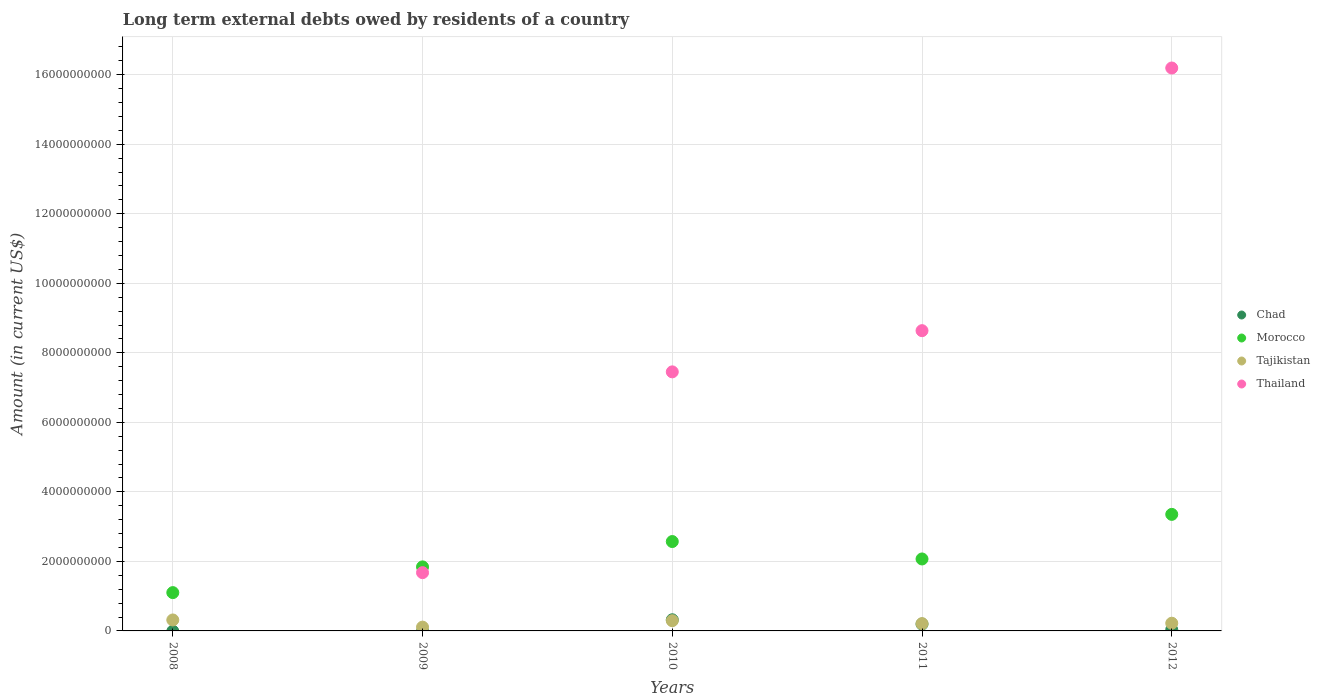How many different coloured dotlines are there?
Provide a succinct answer. 4. Is the number of dotlines equal to the number of legend labels?
Provide a short and direct response. No. What is the amount of long-term external debts owed by residents in Tajikistan in 2012?
Offer a terse response. 2.22e+08. Across all years, what is the maximum amount of long-term external debts owed by residents in Morocco?
Give a very brief answer. 3.35e+09. Across all years, what is the minimum amount of long-term external debts owed by residents in Chad?
Your answer should be very brief. 0. In which year was the amount of long-term external debts owed by residents in Chad maximum?
Your answer should be very brief. 2010. What is the total amount of long-term external debts owed by residents in Thailand in the graph?
Make the answer very short. 3.40e+1. What is the difference between the amount of long-term external debts owed by residents in Tajikistan in 2008 and that in 2012?
Make the answer very short. 9.38e+07. What is the difference between the amount of long-term external debts owed by residents in Chad in 2008 and the amount of long-term external debts owed by residents in Thailand in 2010?
Offer a terse response. -7.45e+09. What is the average amount of long-term external debts owed by residents in Tajikistan per year?
Make the answer very short. 2.30e+08. In the year 2011, what is the difference between the amount of long-term external debts owed by residents in Thailand and amount of long-term external debts owed by residents in Chad?
Offer a terse response. 8.44e+09. What is the ratio of the amount of long-term external debts owed by residents in Tajikistan in 2010 to that in 2012?
Provide a short and direct response. 1.33. Is the amount of long-term external debts owed by residents in Tajikistan in 2008 less than that in 2010?
Provide a short and direct response. No. What is the difference between the highest and the second highest amount of long-term external debts owed by residents in Tajikistan?
Ensure brevity in your answer.  2.15e+07. What is the difference between the highest and the lowest amount of long-term external debts owed by residents in Chad?
Your answer should be very brief. 3.21e+08. In how many years, is the amount of long-term external debts owed by residents in Tajikistan greater than the average amount of long-term external debts owed by residents in Tajikistan taken over all years?
Make the answer very short. 2. Is the sum of the amount of long-term external debts owed by residents in Morocco in 2011 and 2012 greater than the maximum amount of long-term external debts owed by residents in Chad across all years?
Keep it short and to the point. Yes. Is it the case that in every year, the sum of the amount of long-term external debts owed by residents in Tajikistan and amount of long-term external debts owed by residents in Thailand  is greater than the sum of amount of long-term external debts owed by residents in Chad and amount of long-term external debts owed by residents in Morocco?
Keep it short and to the point. No. Does the amount of long-term external debts owed by residents in Chad monotonically increase over the years?
Provide a succinct answer. No. How many years are there in the graph?
Your response must be concise. 5. What is the difference between two consecutive major ticks on the Y-axis?
Your answer should be very brief. 2.00e+09. Where does the legend appear in the graph?
Your response must be concise. Center right. What is the title of the graph?
Offer a very short reply. Long term external debts owed by residents of a country. Does "Barbados" appear as one of the legend labels in the graph?
Offer a terse response. No. What is the label or title of the Y-axis?
Keep it short and to the point. Amount (in current US$). What is the Amount (in current US$) in Chad in 2008?
Ensure brevity in your answer.  0. What is the Amount (in current US$) of Morocco in 2008?
Keep it short and to the point. 1.10e+09. What is the Amount (in current US$) in Tajikistan in 2008?
Your answer should be very brief. 3.15e+08. What is the Amount (in current US$) of Thailand in 2008?
Ensure brevity in your answer.  0. What is the Amount (in current US$) in Morocco in 2009?
Your answer should be very brief. 1.84e+09. What is the Amount (in current US$) of Tajikistan in 2009?
Make the answer very short. 1.09e+08. What is the Amount (in current US$) of Thailand in 2009?
Make the answer very short. 1.68e+09. What is the Amount (in current US$) in Chad in 2010?
Make the answer very short. 3.21e+08. What is the Amount (in current US$) of Morocco in 2010?
Give a very brief answer. 2.57e+09. What is the Amount (in current US$) in Tajikistan in 2010?
Keep it short and to the point. 2.94e+08. What is the Amount (in current US$) in Thailand in 2010?
Your response must be concise. 7.45e+09. What is the Amount (in current US$) of Chad in 2011?
Provide a short and direct response. 1.97e+08. What is the Amount (in current US$) in Morocco in 2011?
Give a very brief answer. 2.07e+09. What is the Amount (in current US$) of Tajikistan in 2011?
Provide a succinct answer. 2.10e+08. What is the Amount (in current US$) of Thailand in 2011?
Ensure brevity in your answer.  8.64e+09. What is the Amount (in current US$) in Chad in 2012?
Ensure brevity in your answer.  3.60e+07. What is the Amount (in current US$) in Morocco in 2012?
Provide a succinct answer. 3.35e+09. What is the Amount (in current US$) of Tajikistan in 2012?
Your answer should be very brief. 2.22e+08. What is the Amount (in current US$) in Thailand in 2012?
Offer a terse response. 1.62e+1. Across all years, what is the maximum Amount (in current US$) in Chad?
Provide a succinct answer. 3.21e+08. Across all years, what is the maximum Amount (in current US$) of Morocco?
Give a very brief answer. 3.35e+09. Across all years, what is the maximum Amount (in current US$) of Tajikistan?
Provide a succinct answer. 3.15e+08. Across all years, what is the maximum Amount (in current US$) in Thailand?
Ensure brevity in your answer.  1.62e+1. Across all years, what is the minimum Amount (in current US$) in Morocco?
Your answer should be compact. 1.10e+09. Across all years, what is the minimum Amount (in current US$) of Tajikistan?
Ensure brevity in your answer.  1.09e+08. Across all years, what is the minimum Amount (in current US$) of Thailand?
Give a very brief answer. 0. What is the total Amount (in current US$) in Chad in the graph?
Provide a succinct answer. 5.54e+08. What is the total Amount (in current US$) in Morocco in the graph?
Your response must be concise. 1.09e+1. What is the total Amount (in current US$) in Tajikistan in the graph?
Your answer should be very brief. 1.15e+09. What is the total Amount (in current US$) of Thailand in the graph?
Your answer should be compact. 3.40e+1. What is the difference between the Amount (in current US$) of Morocco in 2008 and that in 2009?
Your answer should be compact. -7.40e+08. What is the difference between the Amount (in current US$) of Tajikistan in 2008 and that in 2009?
Your response must be concise. 2.06e+08. What is the difference between the Amount (in current US$) in Morocco in 2008 and that in 2010?
Provide a short and direct response. -1.47e+09. What is the difference between the Amount (in current US$) of Tajikistan in 2008 and that in 2010?
Give a very brief answer. 2.15e+07. What is the difference between the Amount (in current US$) of Morocco in 2008 and that in 2011?
Make the answer very short. -9.68e+08. What is the difference between the Amount (in current US$) of Tajikistan in 2008 and that in 2011?
Offer a terse response. 1.05e+08. What is the difference between the Amount (in current US$) of Morocco in 2008 and that in 2012?
Offer a terse response. -2.25e+09. What is the difference between the Amount (in current US$) of Tajikistan in 2008 and that in 2012?
Offer a terse response. 9.38e+07. What is the difference between the Amount (in current US$) of Morocco in 2009 and that in 2010?
Offer a very short reply. -7.29e+08. What is the difference between the Amount (in current US$) of Tajikistan in 2009 and that in 2010?
Your response must be concise. -1.85e+08. What is the difference between the Amount (in current US$) in Thailand in 2009 and that in 2010?
Make the answer very short. -5.78e+09. What is the difference between the Amount (in current US$) of Morocco in 2009 and that in 2011?
Your answer should be compact. -2.28e+08. What is the difference between the Amount (in current US$) of Tajikistan in 2009 and that in 2011?
Your answer should be compact. -1.01e+08. What is the difference between the Amount (in current US$) in Thailand in 2009 and that in 2011?
Ensure brevity in your answer.  -6.96e+09. What is the difference between the Amount (in current US$) of Morocco in 2009 and that in 2012?
Offer a terse response. -1.51e+09. What is the difference between the Amount (in current US$) of Tajikistan in 2009 and that in 2012?
Provide a succinct answer. -1.12e+08. What is the difference between the Amount (in current US$) in Thailand in 2009 and that in 2012?
Your answer should be very brief. -1.45e+1. What is the difference between the Amount (in current US$) of Chad in 2010 and that in 2011?
Your answer should be compact. 1.24e+08. What is the difference between the Amount (in current US$) in Morocco in 2010 and that in 2011?
Your answer should be very brief. 5.01e+08. What is the difference between the Amount (in current US$) of Tajikistan in 2010 and that in 2011?
Your response must be concise. 8.36e+07. What is the difference between the Amount (in current US$) of Thailand in 2010 and that in 2011?
Give a very brief answer. -1.19e+09. What is the difference between the Amount (in current US$) of Chad in 2010 and that in 2012?
Your answer should be very brief. 2.85e+08. What is the difference between the Amount (in current US$) in Morocco in 2010 and that in 2012?
Provide a short and direct response. -7.81e+08. What is the difference between the Amount (in current US$) in Tajikistan in 2010 and that in 2012?
Give a very brief answer. 7.23e+07. What is the difference between the Amount (in current US$) in Thailand in 2010 and that in 2012?
Give a very brief answer. -8.74e+09. What is the difference between the Amount (in current US$) in Chad in 2011 and that in 2012?
Offer a very short reply. 1.61e+08. What is the difference between the Amount (in current US$) in Morocco in 2011 and that in 2012?
Ensure brevity in your answer.  -1.28e+09. What is the difference between the Amount (in current US$) in Tajikistan in 2011 and that in 2012?
Offer a very short reply. -1.13e+07. What is the difference between the Amount (in current US$) of Thailand in 2011 and that in 2012?
Ensure brevity in your answer.  -7.56e+09. What is the difference between the Amount (in current US$) of Morocco in 2008 and the Amount (in current US$) of Tajikistan in 2009?
Provide a short and direct response. 9.93e+08. What is the difference between the Amount (in current US$) in Morocco in 2008 and the Amount (in current US$) in Thailand in 2009?
Ensure brevity in your answer.  -5.74e+08. What is the difference between the Amount (in current US$) of Tajikistan in 2008 and the Amount (in current US$) of Thailand in 2009?
Give a very brief answer. -1.36e+09. What is the difference between the Amount (in current US$) of Morocco in 2008 and the Amount (in current US$) of Tajikistan in 2010?
Your answer should be very brief. 8.08e+08. What is the difference between the Amount (in current US$) in Morocco in 2008 and the Amount (in current US$) in Thailand in 2010?
Your answer should be very brief. -6.35e+09. What is the difference between the Amount (in current US$) of Tajikistan in 2008 and the Amount (in current US$) of Thailand in 2010?
Offer a terse response. -7.14e+09. What is the difference between the Amount (in current US$) of Morocco in 2008 and the Amount (in current US$) of Tajikistan in 2011?
Make the answer very short. 8.92e+08. What is the difference between the Amount (in current US$) in Morocco in 2008 and the Amount (in current US$) in Thailand in 2011?
Your answer should be compact. -7.54e+09. What is the difference between the Amount (in current US$) of Tajikistan in 2008 and the Amount (in current US$) of Thailand in 2011?
Your response must be concise. -8.32e+09. What is the difference between the Amount (in current US$) of Morocco in 2008 and the Amount (in current US$) of Tajikistan in 2012?
Offer a very short reply. 8.80e+08. What is the difference between the Amount (in current US$) of Morocco in 2008 and the Amount (in current US$) of Thailand in 2012?
Your answer should be very brief. -1.51e+1. What is the difference between the Amount (in current US$) of Tajikistan in 2008 and the Amount (in current US$) of Thailand in 2012?
Offer a terse response. -1.59e+1. What is the difference between the Amount (in current US$) of Morocco in 2009 and the Amount (in current US$) of Tajikistan in 2010?
Your response must be concise. 1.55e+09. What is the difference between the Amount (in current US$) in Morocco in 2009 and the Amount (in current US$) in Thailand in 2010?
Make the answer very short. -5.61e+09. What is the difference between the Amount (in current US$) of Tajikistan in 2009 and the Amount (in current US$) of Thailand in 2010?
Your answer should be very brief. -7.34e+09. What is the difference between the Amount (in current US$) in Morocco in 2009 and the Amount (in current US$) in Tajikistan in 2011?
Provide a succinct answer. 1.63e+09. What is the difference between the Amount (in current US$) in Morocco in 2009 and the Amount (in current US$) in Thailand in 2011?
Make the answer very short. -6.80e+09. What is the difference between the Amount (in current US$) in Tajikistan in 2009 and the Amount (in current US$) in Thailand in 2011?
Ensure brevity in your answer.  -8.53e+09. What is the difference between the Amount (in current US$) in Morocco in 2009 and the Amount (in current US$) in Tajikistan in 2012?
Provide a succinct answer. 1.62e+09. What is the difference between the Amount (in current US$) of Morocco in 2009 and the Amount (in current US$) of Thailand in 2012?
Ensure brevity in your answer.  -1.44e+1. What is the difference between the Amount (in current US$) of Tajikistan in 2009 and the Amount (in current US$) of Thailand in 2012?
Make the answer very short. -1.61e+1. What is the difference between the Amount (in current US$) of Chad in 2010 and the Amount (in current US$) of Morocco in 2011?
Offer a very short reply. -1.75e+09. What is the difference between the Amount (in current US$) of Chad in 2010 and the Amount (in current US$) of Tajikistan in 2011?
Provide a short and direct response. 1.10e+08. What is the difference between the Amount (in current US$) of Chad in 2010 and the Amount (in current US$) of Thailand in 2011?
Provide a succinct answer. -8.32e+09. What is the difference between the Amount (in current US$) in Morocco in 2010 and the Amount (in current US$) in Tajikistan in 2011?
Make the answer very short. 2.36e+09. What is the difference between the Amount (in current US$) of Morocco in 2010 and the Amount (in current US$) of Thailand in 2011?
Offer a very short reply. -6.07e+09. What is the difference between the Amount (in current US$) of Tajikistan in 2010 and the Amount (in current US$) of Thailand in 2011?
Ensure brevity in your answer.  -8.34e+09. What is the difference between the Amount (in current US$) of Chad in 2010 and the Amount (in current US$) of Morocco in 2012?
Give a very brief answer. -3.03e+09. What is the difference between the Amount (in current US$) in Chad in 2010 and the Amount (in current US$) in Tajikistan in 2012?
Provide a short and direct response. 9.90e+07. What is the difference between the Amount (in current US$) of Chad in 2010 and the Amount (in current US$) of Thailand in 2012?
Offer a terse response. -1.59e+1. What is the difference between the Amount (in current US$) of Morocco in 2010 and the Amount (in current US$) of Tajikistan in 2012?
Your answer should be compact. 2.35e+09. What is the difference between the Amount (in current US$) in Morocco in 2010 and the Amount (in current US$) in Thailand in 2012?
Provide a succinct answer. -1.36e+1. What is the difference between the Amount (in current US$) in Tajikistan in 2010 and the Amount (in current US$) in Thailand in 2012?
Keep it short and to the point. -1.59e+1. What is the difference between the Amount (in current US$) of Chad in 2011 and the Amount (in current US$) of Morocco in 2012?
Provide a short and direct response. -3.16e+09. What is the difference between the Amount (in current US$) in Chad in 2011 and the Amount (in current US$) in Tajikistan in 2012?
Offer a terse response. -2.48e+07. What is the difference between the Amount (in current US$) in Chad in 2011 and the Amount (in current US$) in Thailand in 2012?
Ensure brevity in your answer.  -1.60e+1. What is the difference between the Amount (in current US$) in Morocco in 2011 and the Amount (in current US$) in Tajikistan in 2012?
Keep it short and to the point. 1.85e+09. What is the difference between the Amount (in current US$) in Morocco in 2011 and the Amount (in current US$) in Thailand in 2012?
Provide a short and direct response. -1.41e+1. What is the difference between the Amount (in current US$) in Tajikistan in 2011 and the Amount (in current US$) in Thailand in 2012?
Provide a short and direct response. -1.60e+1. What is the average Amount (in current US$) in Chad per year?
Provide a succinct answer. 1.11e+08. What is the average Amount (in current US$) in Morocco per year?
Your answer should be compact. 2.19e+09. What is the average Amount (in current US$) in Tajikistan per year?
Make the answer very short. 2.30e+08. What is the average Amount (in current US$) in Thailand per year?
Give a very brief answer. 6.79e+09. In the year 2008, what is the difference between the Amount (in current US$) in Morocco and Amount (in current US$) in Tajikistan?
Keep it short and to the point. 7.86e+08. In the year 2009, what is the difference between the Amount (in current US$) of Morocco and Amount (in current US$) of Tajikistan?
Keep it short and to the point. 1.73e+09. In the year 2009, what is the difference between the Amount (in current US$) in Morocco and Amount (in current US$) in Thailand?
Your answer should be very brief. 1.66e+08. In the year 2009, what is the difference between the Amount (in current US$) in Tajikistan and Amount (in current US$) in Thailand?
Your answer should be compact. -1.57e+09. In the year 2010, what is the difference between the Amount (in current US$) in Chad and Amount (in current US$) in Morocco?
Your response must be concise. -2.25e+09. In the year 2010, what is the difference between the Amount (in current US$) in Chad and Amount (in current US$) in Tajikistan?
Make the answer very short. 2.67e+07. In the year 2010, what is the difference between the Amount (in current US$) of Chad and Amount (in current US$) of Thailand?
Your response must be concise. -7.13e+09. In the year 2010, what is the difference between the Amount (in current US$) in Morocco and Amount (in current US$) in Tajikistan?
Keep it short and to the point. 2.28e+09. In the year 2010, what is the difference between the Amount (in current US$) in Morocco and Amount (in current US$) in Thailand?
Ensure brevity in your answer.  -4.88e+09. In the year 2010, what is the difference between the Amount (in current US$) of Tajikistan and Amount (in current US$) of Thailand?
Your answer should be compact. -7.16e+09. In the year 2011, what is the difference between the Amount (in current US$) in Chad and Amount (in current US$) in Morocco?
Give a very brief answer. -1.87e+09. In the year 2011, what is the difference between the Amount (in current US$) of Chad and Amount (in current US$) of Tajikistan?
Make the answer very short. -1.35e+07. In the year 2011, what is the difference between the Amount (in current US$) in Chad and Amount (in current US$) in Thailand?
Give a very brief answer. -8.44e+09. In the year 2011, what is the difference between the Amount (in current US$) of Morocco and Amount (in current US$) of Tajikistan?
Your answer should be very brief. 1.86e+09. In the year 2011, what is the difference between the Amount (in current US$) of Morocco and Amount (in current US$) of Thailand?
Keep it short and to the point. -6.57e+09. In the year 2011, what is the difference between the Amount (in current US$) in Tajikistan and Amount (in current US$) in Thailand?
Keep it short and to the point. -8.43e+09. In the year 2012, what is the difference between the Amount (in current US$) in Chad and Amount (in current US$) in Morocco?
Your answer should be very brief. -3.32e+09. In the year 2012, what is the difference between the Amount (in current US$) in Chad and Amount (in current US$) in Tajikistan?
Make the answer very short. -1.86e+08. In the year 2012, what is the difference between the Amount (in current US$) in Chad and Amount (in current US$) in Thailand?
Ensure brevity in your answer.  -1.62e+1. In the year 2012, what is the difference between the Amount (in current US$) in Morocco and Amount (in current US$) in Tajikistan?
Your response must be concise. 3.13e+09. In the year 2012, what is the difference between the Amount (in current US$) of Morocco and Amount (in current US$) of Thailand?
Your answer should be very brief. -1.28e+1. In the year 2012, what is the difference between the Amount (in current US$) in Tajikistan and Amount (in current US$) in Thailand?
Give a very brief answer. -1.60e+1. What is the ratio of the Amount (in current US$) of Morocco in 2008 to that in 2009?
Provide a succinct answer. 0.6. What is the ratio of the Amount (in current US$) in Tajikistan in 2008 to that in 2009?
Provide a short and direct response. 2.89. What is the ratio of the Amount (in current US$) in Morocco in 2008 to that in 2010?
Provide a short and direct response. 0.43. What is the ratio of the Amount (in current US$) of Tajikistan in 2008 to that in 2010?
Offer a very short reply. 1.07. What is the ratio of the Amount (in current US$) in Morocco in 2008 to that in 2011?
Your answer should be very brief. 0.53. What is the ratio of the Amount (in current US$) of Tajikistan in 2008 to that in 2011?
Provide a succinct answer. 1.5. What is the ratio of the Amount (in current US$) in Morocco in 2008 to that in 2012?
Your answer should be compact. 0.33. What is the ratio of the Amount (in current US$) of Tajikistan in 2008 to that in 2012?
Make the answer very short. 1.42. What is the ratio of the Amount (in current US$) in Morocco in 2009 to that in 2010?
Provide a succinct answer. 0.72. What is the ratio of the Amount (in current US$) of Tajikistan in 2009 to that in 2010?
Make the answer very short. 0.37. What is the ratio of the Amount (in current US$) in Thailand in 2009 to that in 2010?
Your answer should be very brief. 0.22. What is the ratio of the Amount (in current US$) of Morocco in 2009 to that in 2011?
Make the answer very short. 0.89. What is the ratio of the Amount (in current US$) in Tajikistan in 2009 to that in 2011?
Your answer should be compact. 0.52. What is the ratio of the Amount (in current US$) in Thailand in 2009 to that in 2011?
Give a very brief answer. 0.19. What is the ratio of the Amount (in current US$) of Morocco in 2009 to that in 2012?
Offer a very short reply. 0.55. What is the ratio of the Amount (in current US$) of Tajikistan in 2009 to that in 2012?
Your answer should be compact. 0.49. What is the ratio of the Amount (in current US$) in Thailand in 2009 to that in 2012?
Offer a very short reply. 0.1. What is the ratio of the Amount (in current US$) in Chad in 2010 to that in 2011?
Provide a short and direct response. 1.63. What is the ratio of the Amount (in current US$) in Morocco in 2010 to that in 2011?
Offer a terse response. 1.24. What is the ratio of the Amount (in current US$) in Tajikistan in 2010 to that in 2011?
Offer a terse response. 1.4. What is the ratio of the Amount (in current US$) of Thailand in 2010 to that in 2011?
Your answer should be very brief. 0.86. What is the ratio of the Amount (in current US$) in Chad in 2010 to that in 2012?
Keep it short and to the point. 8.9. What is the ratio of the Amount (in current US$) in Morocco in 2010 to that in 2012?
Keep it short and to the point. 0.77. What is the ratio of the Amount (in current US$) in Tajikistan in 2010 to that in 2012?
Your answer should be very brief. 1.33. What is the ratio of the Amount (in current US$) of Thailand in 2010 to that in 2012?
Ensure brevity in your answer.  0.46. What is the ratio of the Amount (in current US$) of Chad in 2011 to that in 2012?
Offer a terse response. 5.46. What is the ratio of the Amount (in current US$) in Morocco in 2011 to that in 2012?
Your response must be concise. 0.62. What is the ratio of the Amount (in current US$) in Tajikistan in 2011 to that in 2012?
Ensure brevity in your answer.  0.95. What is the ratio of the Amount (in current US$) in Thailand in 2011 to that in 2012?
Make the answer very short. 0.53. What is the difference between the highest and the second highest Amount (in current US$) in Chad?
Provide a short and direct response. 1.24e+08. What is the difference between the highest and the second highest Amount (in current US$) of Morocco?
Make the answer very short. 7.81e+08. What is the difference between the highest and the second highest Amount (in current US$) of Tajikistan?
Your response must be concise. 2.15e+07. What is the difference between the highest and the second highest Amount (in current US$) in Thailand?
Offer a terse response. 7.56e+09. What is the difference between the highest and the lowest Amount (in current US$) of Chad?
Provide a succinct answer. 3.21e+08. What is the difference between the highest and the lowest Amount (in current US$) in Morocco?
Offer a very short reply. 2.25e+09. What is the difference between the highest and the lowest Amount (in current US$) in Tajikistan?
Offer a terse response. 2.06e+08. What is the difference between the highest and the lowest Amount (in current US$) of Thailand?
Your response must be concise. 1.62e+1. 